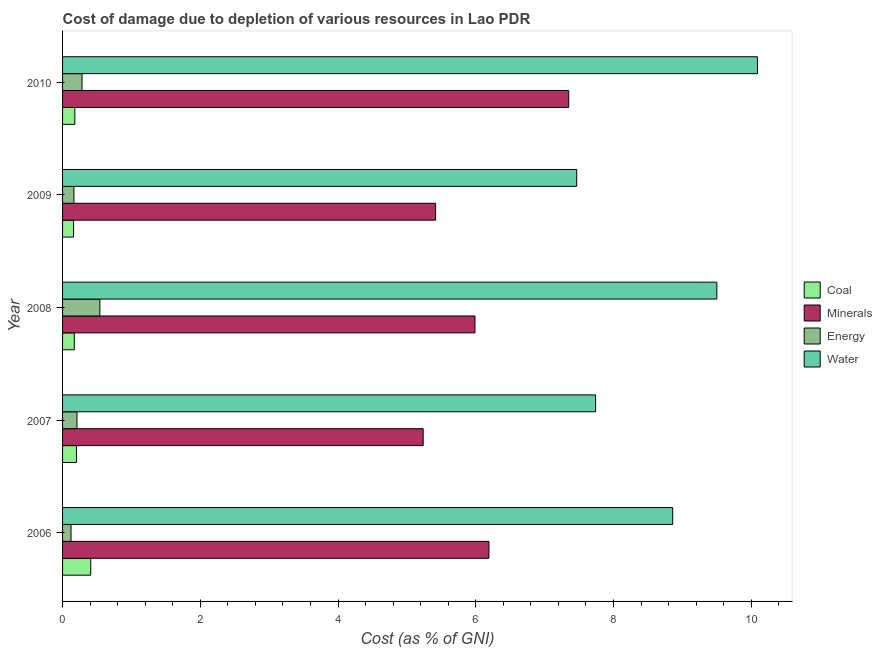How many different coloured bars are there?
Your response must be concise. 4. How many groups of bars are there?
Give a very brief answer. 5. How many bars are there on the 4th tick from the top?
Your answer should be compact. 4. What is the label of the 5th group of bars from the top?
Offer a very short reply. 2006. What is the cost of damage due to depletion of energy in 2009?
Provide a succinct answer. 0.17. Across all years, what is the maximum cost of damage due to depletion of minerals?
Give a very brief answer. 7.35. Across all years, what is the minimum cost of damage due to depletion of water?
Keep it short and to the point. 7.47. In which year was the cost of damage due to depletion of coal maximum?
Provide a short and direct response. 2006. In which year was the cost of damage due to depletion of water minimum?
Offer a terse response. 2009. What is the total cost of damage due to depletion of coal in the graph?
Your response must be concise. 1.12. What is the difference between the cost of damage due to depletion of coal in 2006 and that in 2008?
Ensure brevity in your answer.  0.24. What is the difference between the cost of damage due to depletion of minerals in 2007 and the cost of damage due to depletion of coal in 2006?
Keep it short and to the point. 4.83. What is the average cost of damage due to depletion of coal per year?
Your answer should be compact. 0.22. In the year 2008, what is the difference between the cost of damage due to depletion of minerals and cost of damage due to depletion of coal?
Your answer should be very brief. 5.82. In how many years, is the cost of damage due to depletion of energy greater than 4 %?
Your answer should be very brief. 0. What is the ratio of the cost of damage due to depletion of minerals in 2006 to that in 2007?
Give a very brief answer. 1.18. What is the difference between the highest and the second highest cost of damage due to depletion of energy?
Offer a very short reply. 0.26. What is the difference between the highest and the lowest cost of damage due to depletion of coal?
Your answer should be compact. 0.25. What does the 4th bar from the top in 2006 represents?
Keep it short and to the point. Coal. What does the 2nd bar from the bottom in 2008 represents?
Keep it short and to the point. Minerals. How many bars are there?
Your response must be concise. 20. Are all the bars in the graph horizontal?
Your response must be concise. Yes. Are the values on the major ticks of X-axis written in scientific E-notation?
Give a very brief answer. No. Does the graph contain any zero values?
Ensure brevity in your answer.  No. Does the graph contain grids?
Your answer should be very brief. No. What is the title of the graph?
Keep it short and to the point. Cost of damage due to depletion of various resources in Lao PDR . What is the label or title of the X-axis?
Your response must be concise. Cost (as % of GNI). What is the Cost (as % of GNI) of Coal in 2006?
Your answer should be compact. 0.41. What is the Cost (as % of GNI) of Minerals in 2006?
Keep it short and to the point. 6.19. What is the Cost (as % of GNI) in Energy in 2006?
Give a very brief answer. 0.12. What is the Cost (as % of GNI) in Water in 2006?
Provide a succinct answer. 8.86. What is the Cost (as % of GNI) of Coal in 2007?
Keep it short and to the point. 0.2. What is the Cost (as % of GNI) in Minerals in 2007?
Ensure brevity in your answer.  5.24. What is the Cost (as % of GNI) of Energy in 2007?
Your answer should be compact. 0.21. What is the Cost (as % of GNI) of Water in 2007?
Ensure brevity in your answer.  7.74. What is the Cost (as % of GNI) of Coal in 2008?
Your response must be concise. 0.17. What is the Cost (as % of GNI) of Minerals in 2008?
Provide a succinct answer. 5.99. What is the Cost (as % of GNI) of Energy in 2008?
Your response must be concise. 0.54. What is the Cost (as % of GNI) of Water in 2008?
Your answer should be compact. 9.5. What is the Cost (as % of GNI) in Coal in 2009?
Ensure brevity in your answer.  0.16. What is the Cost (as % of GNI) in Minerals in 2009?
Make the answer very short. 5.42. What is the Cost (as % of GNI) in Energy in 2009?
Keep it short and to the point. 0.17. What is the Cost (as % of GNI) in Water in 2009?
Your answer should be very brief. 7.47. What is the Cost (as % of GNI) of Coal in 2010?
Provide a short and direct response. 0.18. What is the Cost (as % of GNI) of Minerals in 2010?
Make the answer very short. 7.35. What is the Cost (as % of GNI) in Energy in 2010?
Provide a succinct answer. 0.28. What is the Cost (as % of GNI) in Water in 2010?
Offer a very short reply. 10.09. Across all years, what is the maximum Cost (as % of GNI) in Coal?
Your answer should be very brief. 0.41. Across all years, what is the maximum Cost (as % of GNI) in Minerals?
Provide a short and direct response. 7.35. Across all years, what is the maximum Cost (as % of GNI) of Energy?
Your answer should be very brief. 0.54. Across all years, what is the maximum Cost (as % of GNI) of Water?
Provide a short and direct response. 10.09. Across all years, what is the minimum Cost (as % of GNI) in Coal?
Provide a short and direct response. 0.16. Across all years, what is the minimum Cost (as % of GNI) of Minerals?
Your answer should be compact. 5.24. Across all years, what is the minimum Cost (as % of GNI) of Energy?
Offer a very short reply. 0.12. Across all years, what is the minimum Cost (as % of GNI) in Water?
Keep it short and to the point. 7.47. What is the total Cost (as % of GNI) of Coal in the graph?
Make the answer very short. 1.12. What is the total Cost (as % of GNI) of Minerals in the graph?
Ensure brevity in your answer.  30.19. What is the total Cost (as % of GNI) in Energy in the graph?
Offer a terse response. 1.32. What is the total Cost (as % of GNI) of Water in the graph?
Keep it short and to the point. 43.66. What is the difference between the Cost (as % of GNI) in Coal in 2006 and that in 2007?
Your answer should be very brief. 0.21. What is the difference between the Cost (as % of GNI) in Minerals in 2006 and that in 2007?
Your answer should be very brief. 0.95. What is the difference between the Cost (as % of GNI) of Energy in 2006 and that in 2007?
Offer a very short reply. -0.09. What is the difference between the Cost (as % of GNI) in Water in 2006 and that in 2007?
Provide a succinct answer. 1.12. What is the difference between the Cost (as % of GNI) in Coal in 2006 and that in 2008?
Provide a succinct answer. 0.24. What is the difference between the Cost (as % of GNI) of Minerals in 2006 and that in 2008?
Ensure brevity in your answer.  0.2. What is the difference between the Cost (as % of GNI) of Energy in 2006 and that in 2008?
Make the answer very short. -0.42. What is the difference between the Cost (as % of GNI) in Water in 2006 and that in 2008?
Ensure brevity in your answer.  -0.64. What is the difference between the Cost (as % of GNI) in Coal in 2006 and that in 2009?
Your answer should be very brief. 0.25. What is the difference between the Cost (as % of GNI) of Minerals in 2006 and that in 2009?
Offer a very short reply. 0.77. What is the difference between the Cost (as % of GNI) of Energy in 2006 and that in 2009?
Your answer should be compact. -0.04. What is the difference between the Cost (as % of GNI) in Water in 2006 and that in 2009?
Make the answer very short. 1.39. What is the difference between the Cost (as % of GNI) of Coal in 2006 and that in 2010?
Make the answer very short. 0.23. What is the difference between the Cost (as % of GNI) in Minerals in 2006 and that in 2010?
Offer a terse response. -1.16. What is the difference between the Cost (as % of GNI) in Energy in 2006 and that in 2010?
Your answer should be compact. -0.16. What is the difference between the Cost (as % of GNI) of Water in 2006 and that in 2010?
Provide a short and direct response. -1.23. What is the difference between the Cost (as % of GNI) of Coal in 2007 and that in 2008?
Ensure brevity in your answer.  0.03. What is the difference between the Cost (as % of GNI) in Minerals in 2007 and that in 2008?
Provide a short and direct response. -0.75. What is the difference between the Cost (as % of GNI) of Energy in 2007 and that in 2008?
Provide a succinct answer. -0.33. What is the difference between the Cost (as % of GNI) of Water in 2007 and that in 2008?
Provide a short and direct response. -1.76. What is the difference between the Cost (as % of GNI) of Coal in 2007 and that in 2009?
Give a very brief answer. 0.04. What is the difference between the Cost (as % of GNI) in Minerals in 2007 and that in 2009?
Give a very brief answer. -0.18. What is the difference between the Cost (as % of GNI) of Energy in 2007 and that in 2009?
Your response must be concise. 0.04. What is the difference between the Cost (as % of GNI) in Water in 2007 and that in 2009?
Offer a very short reply. 0.27. What is the difference between the Cost (as % of GNI) of Coal in 2007 and that in 2010?
Offer a very short reply. 0.02. What is the difference between the Cost (as % of GNI) in Minerals in 2007 and that in 2010?
Make the answer very short. -2.11. What is the difference between the Cost (as % of GNI) in Energy in 2007 and that in 2010?
Offer a terse response. -0.07. What is the difference between the Cost (as % of GNI) of Water in 2007 and that in 2010?
Your answer should be very brief. -2.35. What is the difference between the Cost (as % of GNI) of Coal in 2008 and that in 2009?
Offer a very short reply. 0.01. What is the difference between the Cost (as % of GNI) in Minerals in 2008 and that in 2009?
Your response must be concise. 0.57. What is the difference between the Cost (as % of GNI) in Energy in 2008 and that in 2009?
Offer a very short reply. 0.38. What is the difference between the Cost (as % of GNI) in Water in 2008 and that in 2009?
Make the answer very short. 2.04. What is the difference between the Cost (as % of GNI) in Coal in 2008 and that in 2010?
Offer a very short reply. -0.01. What is the difference between the Cost (as % of GNI) of Minerals in 2008 and that in 2010?
Provide a short and direct response. -1.36. What is the difference between the Cost (as % of GNI) of Energy in 2008 and that in 2010?
Provide a short and direct response. 0.26. What is the difference between the Cost (as % of GNI) of Water in 2008 and that in 2010?
Keep it short and to the point. -0.59. What is the difference between the Cost (as % of GNI) of Coal in 2009 and that in 2010?
Provide a succinct answer. -0.02. What is the difference between the Cost (as % of GNI) of Minerals in 2009 and that in 2010?
Ensure brevity in your answer.  -1.93. What is the difference between the Cost (as % of GNI) of Energy in 2009 and that in 2010?
Ensure brevity in your answer.  -0.12. What is the difference between the Cost (as % of GNI) in Water in 2009 and that in 2010?
Offer a very short reply. -2.62. What is the difference between the Cost (as % of GNI) in Coal in 2006 and the Cost (as % of GNI) in Minerals in 2007?
Offer a very short reply. -4.83. What is the difference between the Cost (as % of GNI) of Coal in 2006 and the Cost (as % of GNI) of Energy in 2007?
Offer a very short reply. 0.2. What is the difference between the Cost (as % of GNI) in Coal in 2006 and the Cost (as % of GNI) in Water in 2007?
Your response must be concise. -7.33. What is the difference between the Cost (as % of GNI) in Minerals in 2006 and the Cost (as % of GNI) in Energy in 2007?
Keep it short and to the point. 5.98. What is the difference between the Cost (as % of GNI) of Minerals in 2006 and the Cost (as % of GNI) of Water in 2007?
Offer a terse response. -1.55. What is the difference between the Cost (as % of GNI) of Energy in 2006 and the Cost (as % of GNI) of Water in 2007?
Your response must be concise. -7.62. What is the difference between the Cost (as % of GNI) of Coal in 2006 and the Cost (as % of GNI) of Minerals in 2008?
Offer a very short reply. -5.58. What is the difference between the Cost (as % of GNI) of Coal in 2006 and the Cost (as % of GNI) of Energy in 2008?
Your answer should be very brief. -0.13. What is the difference between the Cost (as % of GNI) in Coal in 2006 and the Cost (as % of GNI) in Water in 2008?
Provide a short and direct response. -9.09. What is the difference between the Cost (as % of GNI) in Minerals in 2006 and the Cost (as % of GNI) in Energy in 2008?
Ensure brevity in your answer.  5.65. What is the difference between the Cost (as % of GNI) of Minerals in 2006 and the Cost (as % of GNI) of Water in 2008?
Make the answer very short. -3.31. What is the difference between the Cost (as % of GNI) of Energy in 2006 and the Cost (as % of GNI) of Water in 2008?
Offer a very short reply. -9.38. What is the difference between the Cost (as % of GNI) of Coal in 2006 and the Cost (as % of GNI) of Minerals in 2009?
Give a very brief answer. -5.01. What is the difference between the Cost (as % of GNI) of Coal in 2006 and the Cost (as % of GNI) of Energy in 2009?
Ensure brevity in your answer.  0.24. What is the difference between the Cost (as % of GNI) of Coal in 2006 and the Cost (as % of GNI) of Water in 2009?
Provide a succinct answer. -7.06. What is the difference between the Cost (as % of GNI) in Minerals in 2006 and the Cost (as % of GNI) in Energy in 2009?
Provide a short and direct response. 6.03. What is the difference between the Cost (as % of GNI) in Minerals in 2006 and the Cost (as % of GNI) in Water in 2009?
Your answer should be compact. -1.27. What is the difference between the Cost (as % of GNI) in Energy in 2006 and the Cost (as % of GNI) in Water in 2009?
Make the answer very short. -7.34. What is the difference between the Cost (as % of GNI) in Coal in 2006 and the Cost (as % of GNI) in Minerals in 2010?
Your response must be concise. -6.94. What is the difference between the Cost (as % of GNI) in Coal in 2006 and the Cost (as % of GNI) in Energy in 2010?
Keep it short and to the point. 0.13. What is the difference between the Cost (as % of GNI) in Coal in 2006 and the Cost (as % of GNI) in Water in 2010?
Keep it short and to the point. -9.68. What is the difference between the Cost (as % of GNI) in Minerals in 2006 and the Cost (as % of GNI) in Energy in 2010?
Keep it short and to the point. 5.91. What is the difference between the Cost (as % of GNI) of Minerals in 2006 and the Cost (as % of GNI) of Water in 2010?
Offer a very short reply. -3.9. What is the difference between the Cost (as % of GNI) of Energy in 2006 and the Cost (as % of GNI) of Water in 2010?
Offer a terse response. -9.97. What is the difference between the Cost (as % of GNI) of Coal in 2007 and the Cost (as % of GNI) of Minerals in 2008?
Your answer should be very brief. -5.79. What is the difference between the Cost (as % of GNI) in Coal in 2007 and the Cost (as % of GNI) in Energy in 2008?
Offer a very short reply. -0.34. What is the difference between the Cost (as % of GNI) in Coal in 2007 and the Cost (as % of GNI) in Water in 2008?
Your answer should be compact. -9.3. What is the difference between the Cost (as % of GNI) in Minerals in 2007 and the Cost (as % of GNI) in Energy in 2008?
Your answer should be compact. 4.69. What is the difference between the Cost (as % of GNI) of Minerals in 2007 and the Cost (as % of GNI) of Water in 2008?
Offer a very short reply. -4.26. What is the difference between the Cost (as % of GNI) in Energy in 2007 and the Cost (as % of GNI) in Water in 2008?
Provide a succinct answer. -9.29. What is the difference between the Cost (as % of GNI) in Coal in 2007 and the Cost (as % of GNI) in Minerals in 2009?
Offer a terse response. -5.22. What is the difference between the Cost (as % of GNI) of Coal in 2007 and the Cost (as % of GNI) of Energy in 2009?
Offer a very short reply. 0.04. What is the difference between the Cost (as % of GNI) in Coal in 2007 and the Cost (as % of GNI) in Water in 2009?
Provide a short and direct response. -7.26. What is the difference between the Cost (as % of GNI) of Minerals in 2007 and the Cost (as % of GNI) of Energy in 2009?
Your answer should be very brief. 5.07. What is the difference between the Cost (as % of GNI) of Minerals in 2007 and the Cost (as % of GNI) of Water in 2009?
Provide a short and direct response. -2.23. What is the difference between the Cost (as % of GNI) in Energy in 2007 and the Cost (as % of GNI) in Water in 2009?
Your response must be concise. -7.26. What is the difference between the Cost (as % of GNI) of Coal in 2007 and the Cost (as % of GNI) of Minerals in 2010?
Offer a terse response. -7.15. What is the difference between the Cost (as % of GNI) in Coal in 2007 and the Cost (as % of GNI) in Energy in 2010?
Offer a very short reply. -0.08. What is the difference between the Cost (as % of GNI) in Coal in 2007 and the Cost (as % of GNI) in Water in 2010?
Your response must be concise. -9.89. What is the difference between the Cost (as % of GNI) in Minerals in 2007 and the Cost (as % of GNI) in Energy in 2010?
Provide a short and direct response. 4.95. What is the difference between the Cost (as % of GNI) of Minerals in 2007 and the Cost (as % of GNI) of Water in 2010?
Give a very brief answer. -4.85. What is the difference between the Cost (as % of GNI) of Energy in 2007 and the Cost (as % of GNI) of Water in 2010?
Your answer should be very brief. -9.88. What is the difference between the Cost (as % of GNI) in Coal in 2008 and the Cost (as % of GNI) in Minerals in 2009?
Make the answer very short. -5.25. What is the difference between the Cost (as % of GNI) in Coal in 2008 and the Cost (as % of GNI) in Energy in 2009?
Provide a succinct answer. 0.01. What is the difference between the Cost (as % of GNI) of Coal in 2008 and the Cost (as % of GNI) of Water in 2009?
Make the answer very short. -7.3. What is the difference between the Cost (as % of GNI) in Minerals in 2008 and the Cost (as % of GNI) in Energy in 2009?
Your answer should be compact. 5.82. What is the difference between the Cost (as % of GNI) in Minerals in 2008 and the Cost (as % of GNI) in Water in 2009?
Provide a short and direct response. -1.48. What is the difference between the Cost (as % of GNI) of Energy in 2008 and the Cost (as % of GNI) of Water in 2009?
Your answer should be very brief. -6.92. What is the difference between the Cost (as % of GNI) of Coal in 2008 and the Cost (as % of GNI) of Minerals in 2010?
Offer a very short reply. -7.18. What is the difference between the Cost (as % of GNI) of Coal in 2008 and the Cost (as % of GNI) of Energy in 2010?
Your answer should be compact. -0.11. What is the difference between the Cost (as % of GNI) of Coal in 2008 and the Cost (as % of GNI) of Water in 2010?
Offer a very short reply. -9.92. What is the difference between the Cost (as % of GNI) of Minerals in 2008 and the Cost (as % of GNI) of Energy in 2010?
Give a very brief answer. 5.71. What is the difference between the Cost (as % of GNI) in Minerals in 2008 and the Cost (as % of GNI) in Water in 2010?
Keep it short and to the point. -4.1. What is the difference between the Cost (as % of GNI) of Energy in 2008 and the Cost (as % of GNI) of Water in 2010?
Keep it short and to the point. -9.55. What is the difference between the Cost (as % of GNI) of Coal in 2009 and the Cost (as % of GNI) of Minerals in 2010?
Keep it short and to the point. -7.19. What is the difference between the Cost (as % of GNI) in Coal in 2009 and the Cost (as % of GNI) in Energy in 2010?
Give a very brief answer. -0.12. What is the difference between the Cost (as % of GNI) of Coal in 2009 and the Cost (as % of GNI) of Water in 2010?
Keep it short and to the point. -9.93. What is the difference between the Cost (as % of GNI) in Minerals in 2009 and the Cost (as % of GNI) in Energy in 2010?
Provide a succinct answer. 5.13. What is the difference between the Cost (as % of GNI) in Minerals in 2009 and the Cost (as % of GNI) in Water in 2010?
Make the answer very short. -4.67. What is the difference between the Cost (as % of GNI) in Energy in 2009 and the Cost (as % of GNI) in Water in 2010?
Provide a succinct answer. -9.93. What is the average Cost (as % of GNI) of Coal per year?
Your response must be concise. 0.22. What is the average Cost (as % of GNI) in Minerals per year?
Offer a terse response. 6.04. What is the average Cost (as % of GNI) of Energy per year?
Your response must be concise. 0.26. What is the average Cost (as % of GNI) in Water per year?
Your response must be concise. 8.73. In the year 2006, what is the difference between the Cost (as % of GNI) of Coal and Cost (as % of GNI) of Minerals?
Keep it short and to the point. -5.78. In the year 2006, what is the difference between the Cost (as % of GNI) in Coal and Cost (as % of GNI) in Energy?
Provide a succinct answer. 0.29. In the year 2006, what is the difference between the Cost (as % of GNI) of Coal and Cost (as % of GNI) of Water?
Offer a terse response. -8.45. In the year 2006, what is the difference between the Cost (as % of GNI) in Minerals and Cost (as % of GNI) in Energy?
Make the answer very short. 6.07. In the year 2006, what is the difference between the Cost (as % of GNI) of Minerals and Cost (as % of GNI) of Water?
Keep it short and to the point. -2.67. In the year 2006, what is the difference between the Cost (as % of GNI) in Energy and Cost (as % of GNI) in Water?
Keep it short and to the point. -8.74. In the year 2007, what is the difference between the Cost (as % of GNI) of Coal and Cost (as % of GNI) of Minerals?
Offer a terse response. -5.03. In the year 2007, what is the difference between the Cost (as % of GNI) of Coal and Cost (as % of GNI) of Energy?
Ensure brevity in your answer.  -0.01. In the year 2007, what is the difference between the Cost (as % of GNI) in Coal and Cost (as % of GNI) in Water?
Offer a very short reply. -7.54. In the year 2007, what is the difference between the Cost (as % of GNI) in Minerals and Cost (as % of GNI) in Energy?
Keep it short and to the point. 5.03. In the year 2007, what is the difference between the Cost (as % of GNI) of Minerals and Cost (as % of GNI) of Water?
Your answer should be compact. -2.5. In the year 2007, what is the difference between the Cost (as % of GNI) in Energy and Cost (as % of GNI) in Water?
Give a very brief answer. -7.53. In the year 2008, what is the difference between the Cost (as % of GNI) of Coal and Cost (as % of GNI) of Minerals?
Make the answer very short. -5.82. In the year 2008, what is the difference between the Cost (as % of GNI) in Coal and Cost (as % of GNI) in Energy?
Provide a succinct answer. -0.37. In the year 2008, what is the difference between the Cost (as % of GNI) of Coal and Cost (as % of GNI) of Water?
Give a very brief answer. -9.33. In the year 2008, what is the difference between the Cost (as % of GNI) of Minerals and Cost (as % of GNI) of Energy?
Make the answer very short. 5.45. In the year 2008, what is the difference between the Cost (as % of GNI) in Minerals and Cost (as % of GNI) in Water?
Offer a terse response. -3.51. In the year 2008, what is the difference between the Cost (as % of GNI) of Energy and Cost (as % of GNI) of Water?
Your answer should be compact. -8.96. In the year 2009, what is the difference between the Cost (as % of GNI) in Coal and Cost (as % of GNI) in Minerals?
Your answer should be very brief. -5.26. In the year 2009, what is the difference between the Cost (as % of GNI) of Coal and Cost (as % of GNI) of Energy?
Your answer should be very brief. -0.01. In the year 2009, what is the difference between the Cost (as % of GNI) in Coal and Cost (as % of GNI) in Water?
Keep it short and to the point. -7.31. In the year 2009, what is the difference between the Cost (as % of GNI) of Minerals and Cost (as % of GNI) of Energy?
Keep it short and to the point. 5.25. In the year 2009, what is the difference between the Cost (as % of GNI) of Minerals and Cost (as % of GNI) of Water?
Keep it short and to the point. -2.05. In the year 2009, what is the difference between the Cost (as % of GNI) in Energy and Cost (as % of GNI) in Water?
Keep it short and to the point. -7.3. In the year 2010, what is the difference between the Cost (as % of GNI) of Coal and Cost (as % of GNI) of Minerals?
Your response must be concise. -7.17. In the year 2010, what is the difference between the Cost (as % of GNI) of Coal and Cost (as % of GNI) of Energy?
Your response must be concise. -0.1. In the year 2010, what is the difference between the Cost (as % of GNI) of Coal and Cost (as % of GNI) of Water?
Your response must be concise. -9.91. In the year 2010, what is the difference between the Cost (as % of GNI) of Minerals and Cost (as % of GNI) of Energy?
Provide a succinct answer. 7.07. In the year 2010, what is the difference between the Cost (as % of GNI) in Minerals and Cost (as % of GNI) in Water?
Your answer should be very brief. -2.74. In the year 2010, what is the difference between the Cost (as % of GNI) of Energy and Cost (as % of GNI) of Water?
Your answer should be compact. -9.81. What is the ratio of the Cost (as % of GNI) in Coal in 2006 to that in 2007?
Offer a very short reply. 2.03. What is the ratio of the Cost (as % of GNI) in Minerals in 2006 to that in 2007?
Provide a short and direct response. 1.18. What is the ratio of the Cost (as % of GNI) in Energy in 2006 to that in 2007?
Keep it short and to the point. 0.59. What is the ratio of the Cost (as % of GNI) of Water in 2006 to that in 2007?
Make the answer very short. 1.14. What is the ratio of the Cost (as % of GNI) in Coal in 2006 to that in 2008?
Ensure brevity in your answer.  2.4. What is the ratio of the Cost (as % of GNI) of Minerals in 2006 to that in 2008?
Ensure brevity in your answer.  1.03. What is the ratio of the Cost (as % of GNI) of Energy in 2006 to that in 2008?
Give a very brief answer. 0.23. What is the ratio of the Cost (as % of GNI) in Water in 2006 to that in 2008?
Your answer should be very brief. 0.93. What is the ratio of the Cost (as % of GNI) in Coal in 2006 to that in 2009?
Make the answer very short. 2.56. What is the ratio of the Cost (as % of GNI) of Minerals in 2006 to that in 2009?
Keep it short and to the point. 1.14. What is the ratio of the Cost (as % of GNI) of Energy in 2006 to that in 2009?
Ensure brevity in your answer.  0.74. What is the ratio of the Cost (as % of GNI) of Water in 2006 to that in 2009?
Ensure brevity in your answer.  1.19. What is the ratio of the Cost (as % of GNI) in Coal in 2006 to that in 2010?
Provide a succinct answer. 2.3. What is the ratio of the Cost (as % of GNI) in Minerals in 2006 to that in 2010?
Your answer should be very brief. 0.84. What is the ratio of the Cost (as % of GNI) in Energy in 2006 to that in 2010?
Your answer should be compact. 0.43. What is the ratio of the Cost (as % of GNI) of Water in 2006 to that in 2010?
Provide a short and direct response. 0.88. What is the ratio of the Cost (as % of GNI) in Coal in 2007 to that in 2008?
Your response must be concise. 1.18. What is the ratio of the Cost (as % of GNI) in Minerals in 2007 to that in 2008?
Keep it short and to the point. 0.87. What is the ratio of the Cost (as % of GNI) in Energy in 2007 to that in 2008?
Make the answer very short. 0.39. What is the ratio of the Cost (as % of GNI) of Water in 2007 to that in 2008?
Your response must be concise. 0.81. What is the ratio of the Cost (as % of GNI) of Coal in 2007 to that in 2009?
Your answer should be very brief. 1.26. What is the ratio of the Cost (as % of GNI) of Minerals in 2007 to that in 2009?
Provide a short and direct response. 0.97. What is the ratio of the Cost (as % of GNI) in Energy in 2007 to that in 2009?
Your response must be concise. 1.26. What is the ratio of the Cost (as % of GNI) in Water in 2007 to that in 2009?
Keep it short and to the point. 1.04. What is the ratio of the Cost (as % of GNI) in Coal in 2007 to that in 2010?
Your answer should be compact. 1.13. What is the ratio of the Cost (as % of GNI) of Minerals in 2007 to that in 2010?
Give a very brief answer. 0.71. What is the ratio of the Cost (as % of GNI) of Energy in 2007 to that in 2010?
Offer a terse response. 0.74. What is the ratio of the Cost (as % of GNI) in Water in 2007 to that in 2010?
Make the answer very short. 0.77. What is the ratio of the Cost (as % of GNI) in Coal in 2008 to that in 2009?
Provide a succinct answer. 1.06. What is the ratio of the Cost (as % of GNI) in Minerals in 2008 to that in 2009?
Provide a short and direct response. 1.11. What is the ratio of the Cost (as % of GNI) in Energy in 2008 to that in 2009?
Keep it short and to the point. 3.28. What is the ratio of the Cost (as % of GNI) of Water in 2008 to that in 2009?
Offer a very short reply. 1.27. What is the ratio of the Cost (as % of GNI) of Coal in 2008 to that in 2010?
Your response must be concise. 0.96. What is the ratio of the Cost (as % of GNI) in Minerals in 2008 to that in 2010?
Your response must be concise. 0.81. What is the ratio of the Cost (as % of GNI) of Energy in 2008 to that in 2010?
Make the answer very short. 1.92. What is the ratio of the Cost (as % of GNI) of Water in 2008 to that in 2010?
Provide a succinct answer. 0.94. What is the ratio of the Cost (as % of GNI) of Coal in 2009 to that in 2010?
Give a very brief answer. 0.9. What is the ratio of the Cost (as % of GNI) in Minerals in 2009 to that in 2010?
Ensure brevity in your answer.  0.74. What is the ratio of the Cost (as % of GNI) of Energy in 2009 to that in 2010?
Offer a very short reply. 0.58. What is the ratio of the Cost (as % of GNI) of Water in 2009 to that in 2010?
Offer a terse response. 0.74. What is the difference between the highest and the second highest Cost (as % of GNI) of Coal?
Give a very brief answer. 0.21. What is the difference between the highest and the second highest Cost (as % of GNI) of Minerals?
Provide a short and direct response. 1.16. What is the difference between the highest and the second highest Cost (as % of GNI) in Energy?
Ensure brevity in your answer.  0.26. What is the difference between the highest and the second highest Cost (as % of GNI) of Water?
Provide a short and direct response. 0.59. What is the difference between the highest and the lowest Cost (as % of GNI) in Coal?
Ensure brevity in your answer.  0.25. What is the difference between the highest and the lowest Cost (as % of GNI) in Minerals?
Your response must be concise. 2.11. What is the difference between the highest and the lowest Cost (as % of GNI) in Energy?
Provide a short and direct response. 0.42. What is the difference between the highest and the lowest Cost (as % of GNI) of Water?
Your response must be concise. 2.62. 